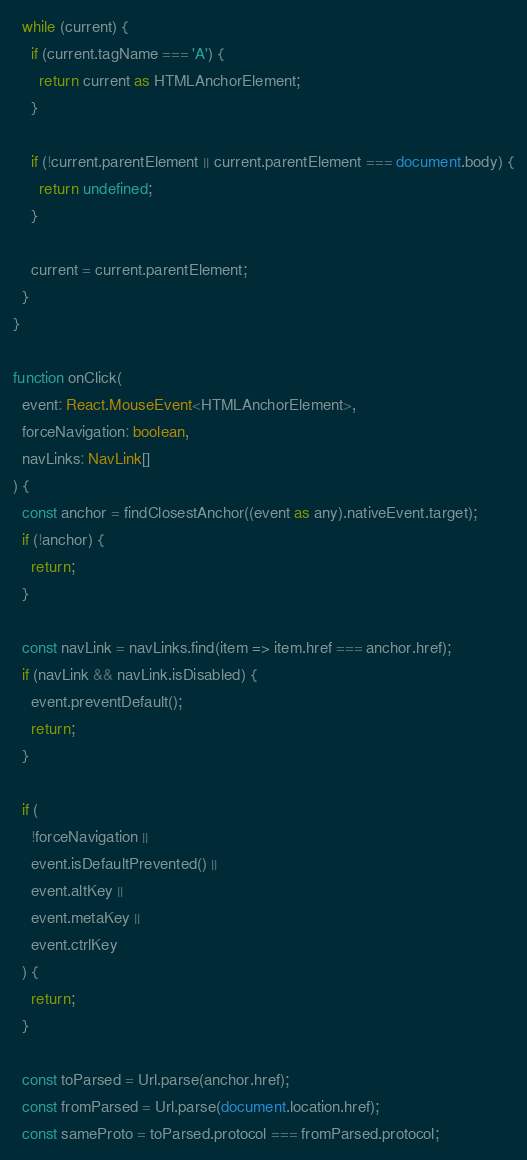<code> <loc_0><loc_0><loc_500><loc_500><_TypeScript_>  while (current) {
    if (current.tagName === 'A') {
      return current as HTMLAnchorElement;
    }

    if (!current.parentElement || current.parentElement === document.body) {
      return undefined;
    }

    current = current.parentElement;
  }
}

function onClick(
  event: React.MouseEvent<HTMLAnchorElement>,
  forceNavigation: boolean,
  navLinks: NavLink[]
) {
  const anchor = findClosestAnchor((event as any).nativeEvent.target);
  if (!anchor) {
    return;
  }

  const navLink = navLinks.find(item => item.href === anchor.href);
  if (navLink && navLink.isDisabled) {
    event.preventDefault();
    return;
  }

  if (
    !forceNavigation ||
    event.isDefaultPrevented() ||
    event.altKey ||
    event.metaKey ||
    event.ctrlKey
  ) {
    return;
  }

  const toParsed = Url.parse(anchor.href);
  const fromParsed = Url.parse(document.location.href);
  const sameProto = toParsed.protocol === fromParsed.protocol;</code> 